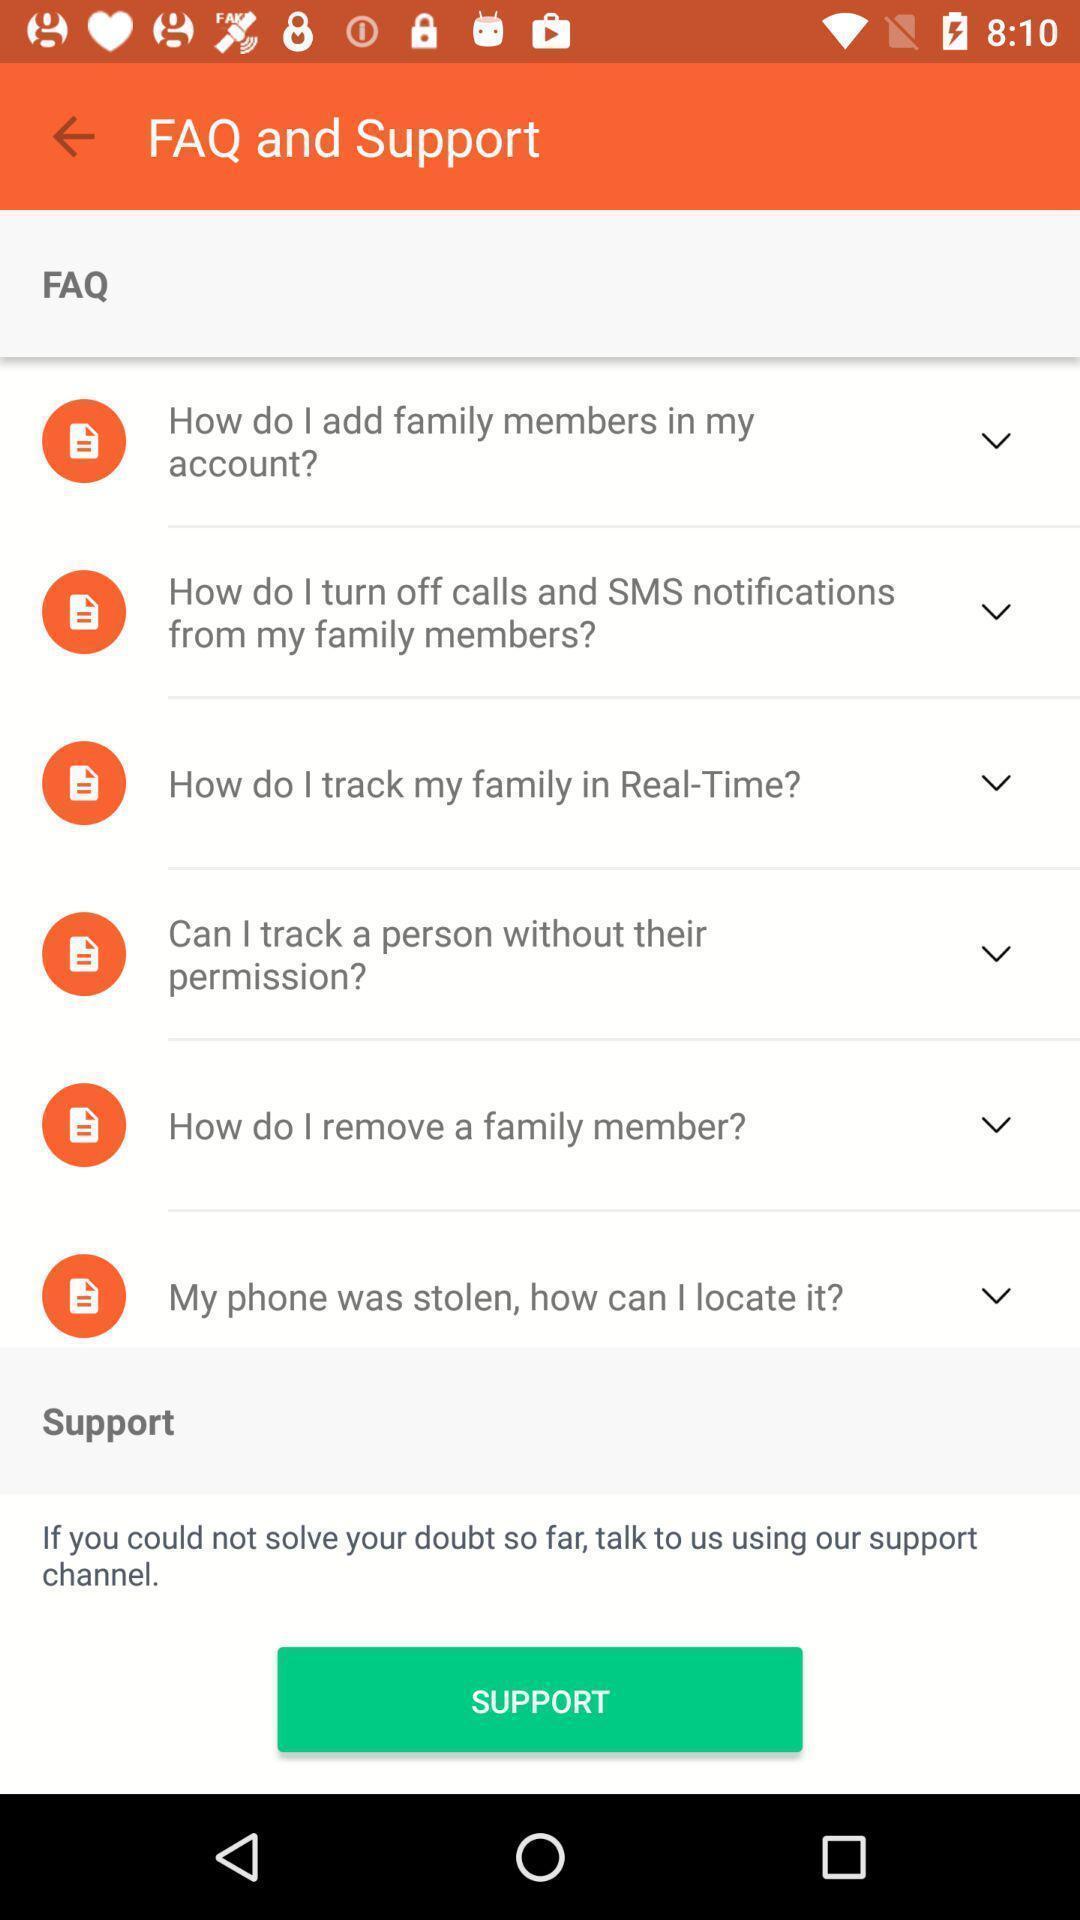Give me a narrative description of this picture. Screen displaying list of faq. 